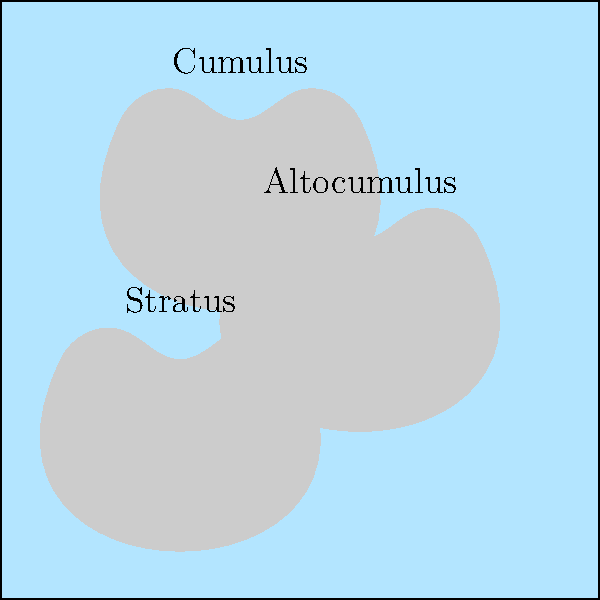Based on the cloud formations shown in the image, which of the following herbs would be most beneficial to gather today?

A) Sunroot, which thrives in direct sunlight
B) Moonleaf, which prefers cooler, overcast conditions
C) Rainbloom, which flourishes just before precipitation
D) Windwhisper, which grows best in strong breezes To answer this question, we need to interpret the cloud formations and their implications for the weather:

1. The image shows three types of clouds:
   - Cumulus: Fluffy, white clouds at low altitudes
   - Altocumulus: Small, roundish clouds at medium altitudes
   - Stratus: Low-lying, flat, uniform clouds

2. Interpreting these cloud formations:
   - Cumulus clouds often indicate fair weather but can develop into storm clouds later in the day
   - Altocumulus clouds suggest a change in weather may be coming, possibly within 24 hours
   - Stratus clouds typically bring overcast conditions and possibly light precipitation

3. Considering the combination of these cloud types:
   - The presence of all three suggests a transitional weather pattern
   - The sky is not completely overcast, but it's not clear either
   - There's a possibility of light rain or cooler temperatures

4. Relating this to herb gathering:
   - Sunroot needs direct sunlight, which is not guaranteed with this cloud cover
   - Rainbloom prefers conditions just before heavy rain, which is not indicated here
   - Windwhisper requires strong breezes, which are not typically associated with these cloud types

5. Conclusion:
   - Moonleaf, which prefers cooler and overcast conditions, would be the most suitable herb to gather given these weather indicators

Therefore, the most beneficial herb to gather today would be Moonleaf.
Answer: B) Moonleaf 